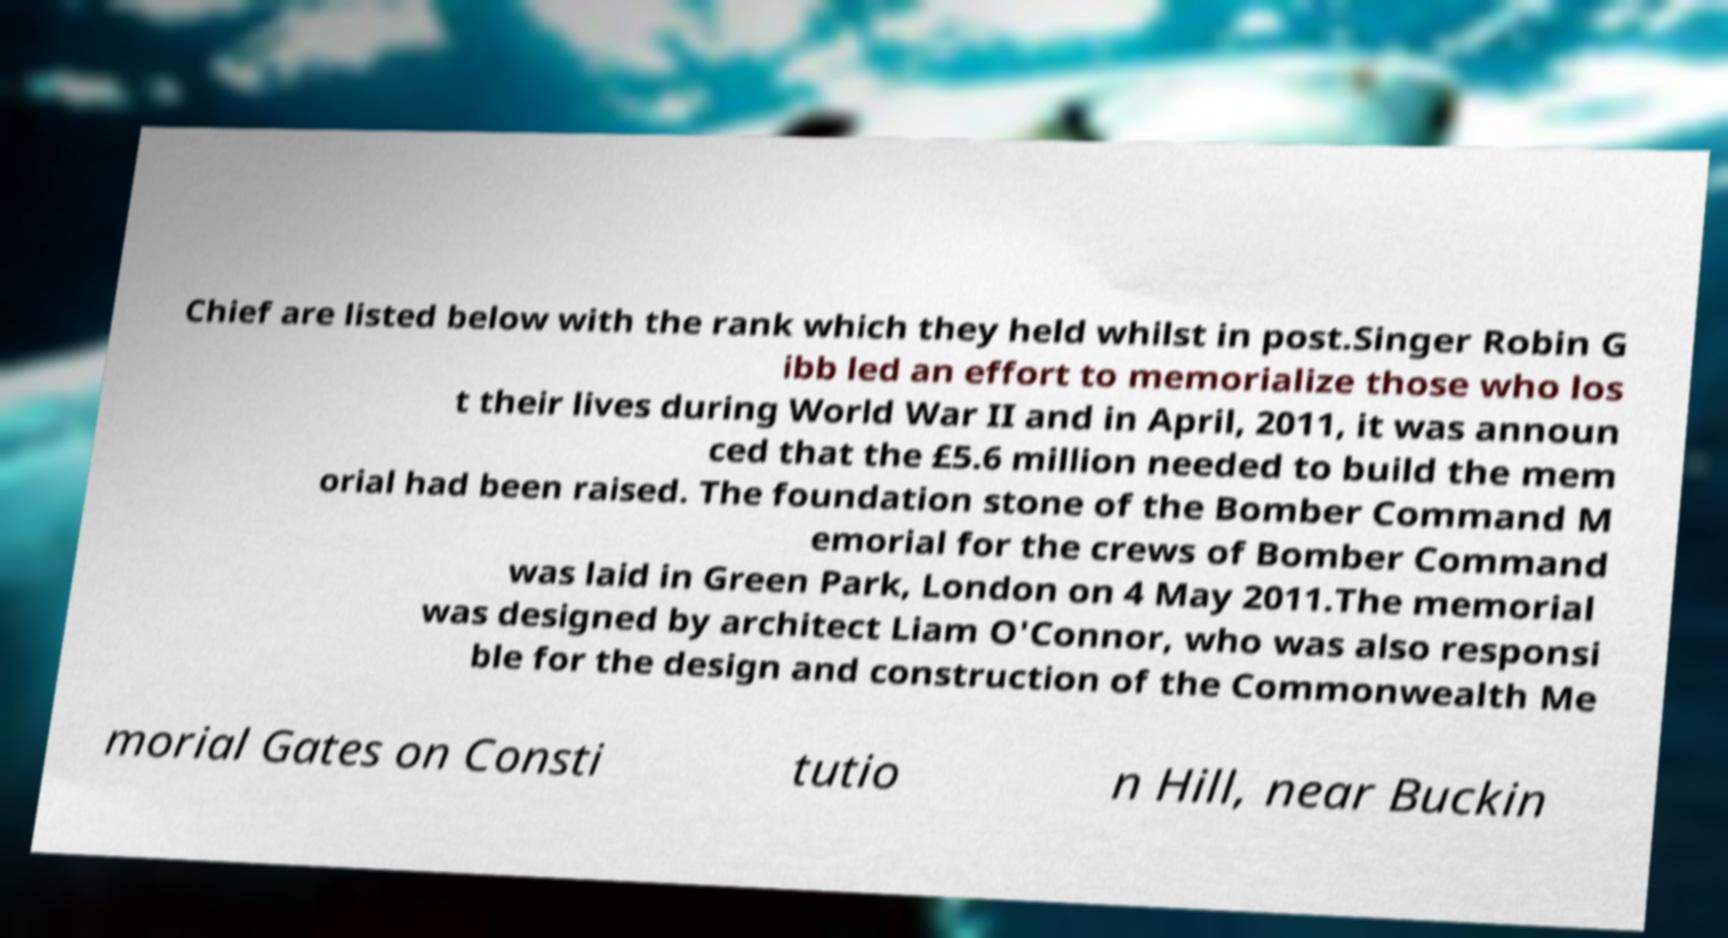What messages or text are displayed in this image? I need them in a readable, typed format. Chief are listed below with the rank which they held whilst in post.Singer Robin G ibb led an effort to memorialize those who los t their lives during World War II and in April, 2011, it was announ ced that the £5.6 million needed to build the mem orial had been raised. The foundation stone of the Bomber Command M emorial for the crews of Bomber Command was laid in Green Park, London on 4 May 2011.The memorial was designed by architect Liam O'Connor, who was also responsi ble for the design and construction of the Commonwealth Me morial Gates on Consti tutio n Hill, near Buckin 